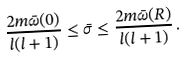Convert formula to latex. <formula><loc_0><loc_0><loc_500><loc_500>\frac { 2 m \bar { \omega } ( 0 ) } { l ( l + 1 ) } \leq \bar { \sigma } \leq \frac { 2 m \bar { \omega } ( R ) } { l ( l + 1 ) } \, .</formula> 